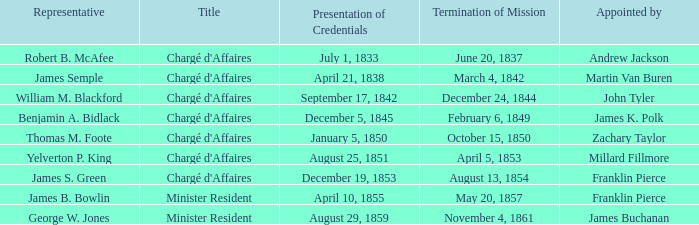What's the Termination of Mission listed that has a Presentation of Credentials for August 29, 1859? November 4, 1861. 